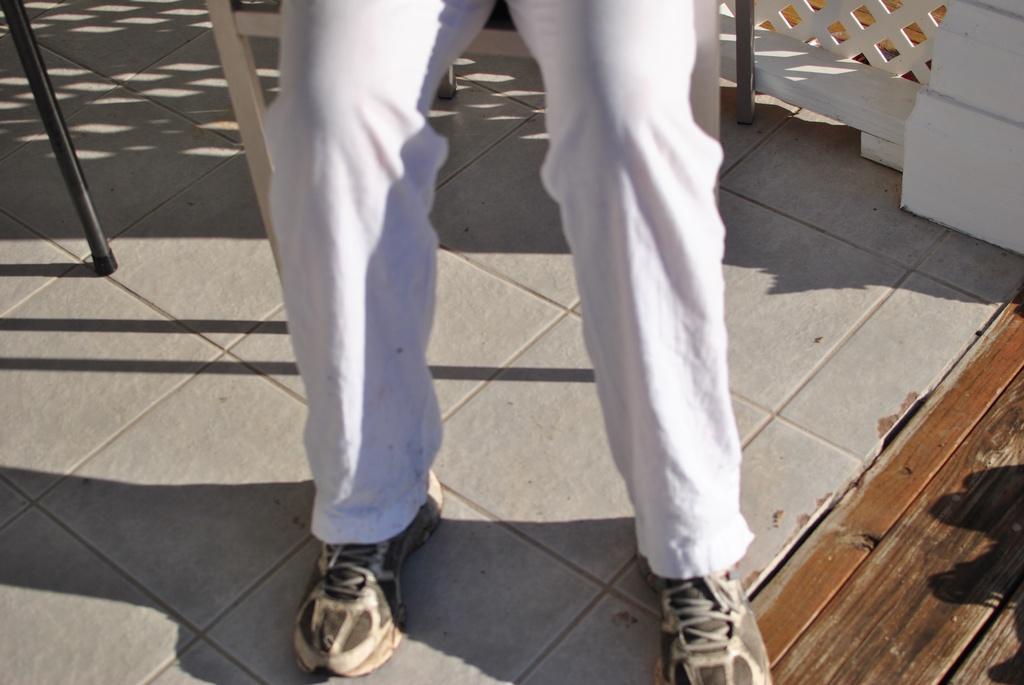Could you give a brief overview of what you see in this image? in this image we can see a person´s legs on the floor, it looks like the person is sitting on a chair, in the background there is a fence and on the left side of the image there is a black color rod. 